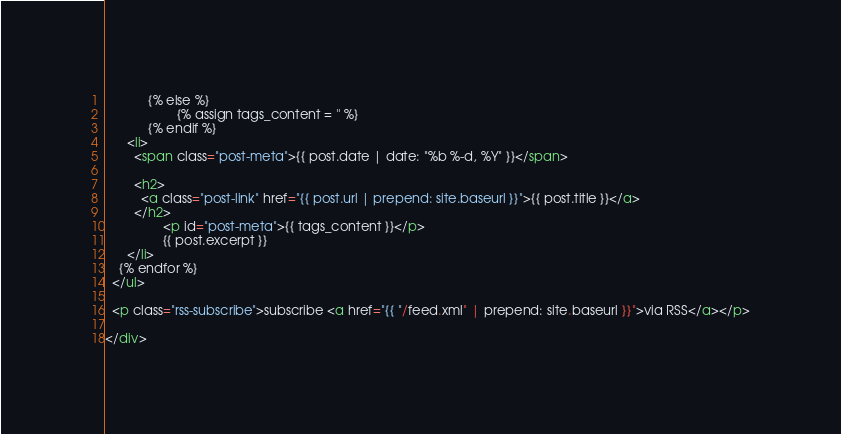Convert code to text. <code><loc_0><loc_0><loc_500><loc_500><_HTML_>			{% else %}
					{% assign tags_content = '' %}
			{% endif %}
      <li>
        <span class="post-meta">{{ post.date | date: "%b %-d, %Y" }}</span>

        <h2>
          <a class="post-link" href="{{ post.url | prepend: site.baseurl }}">{{ post.title }}</a>
        </h2>
				<p id="post-meta">{{ tags_content }}</p>
				{{ post.excerpt }}
      </li>
    {% endfor %}
  </ul>

  <p class="rss-subscribe">subscribe <a href="{{ "/feed.xml" | prepend: site.baseurl }}">via RSS</a></p>

</div>
</code> 